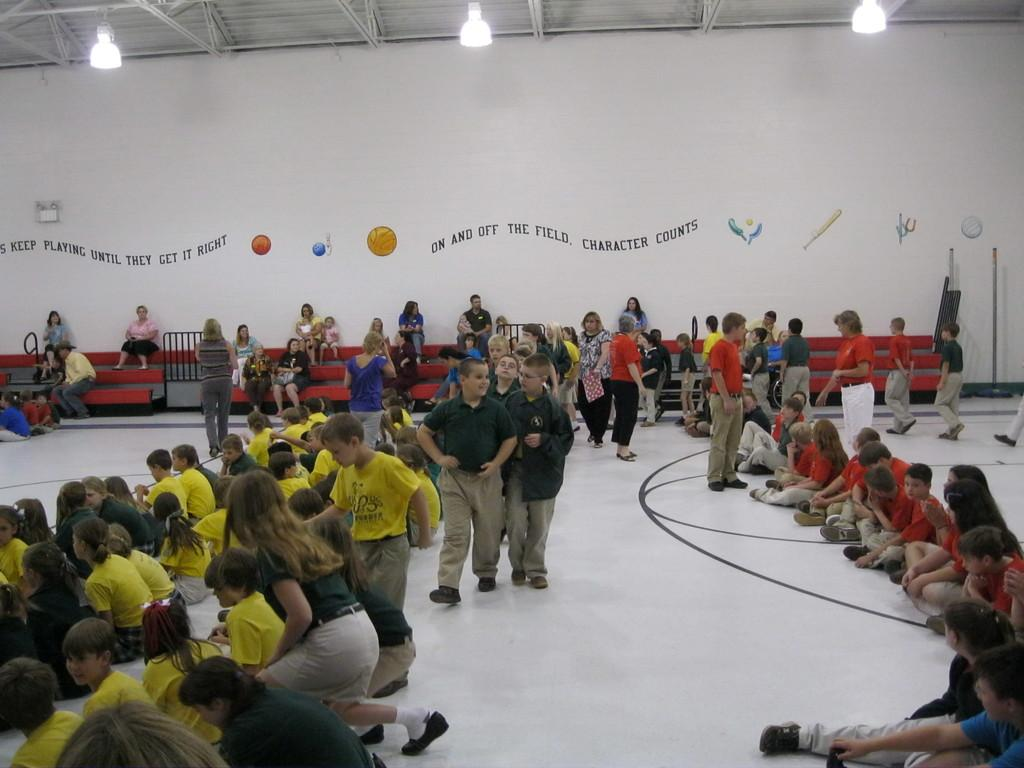What are the people in the image doing? There are people seated, walking, and standing in the image. What can be seen on the wall in the image? There is text and pictures on the wall in the image. What is present on the ceiling in the image? There are lights on the ceiling in the image. What is the weight of the comb used by the person in the image? There is no comb present in the image, so it is not possible to determine its weight. 